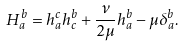<formula> <loc_0><loc_0><loc_500><loc_500>H _ { a } ^ { b } = h _ { a } ^ { c } h _ { c } ^ { b } + \frac { \nu } { 2 \mu } h _ { a } ^ { b } - \mu \delta _ { a } ^ { b } .</formula> 